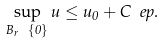Convert formula to latex. <formula><loc_0><loc_0><loc_500><loc_500>\sup _ { B _ { r } \ \{ 0 \} } u \leq u _ { 0 } + C \ e p .</formula> 